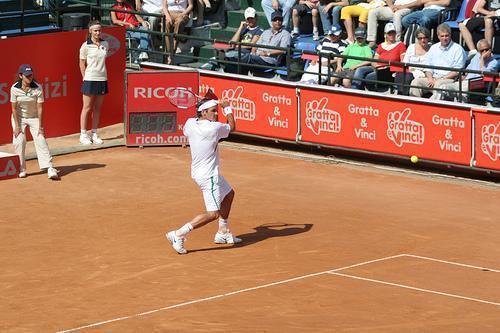Why is the man swinging his arms?
Pick the correct solution from the four options below to address the question.
Options: Dancing, stretching, swatting flies, swatting ball. Swatting ball. 